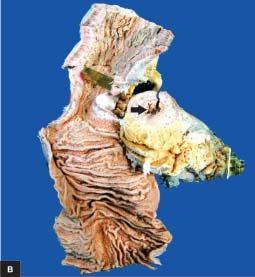what does external surface show?
Answer the question using a single word or phrase. Increased mesenteric fat 